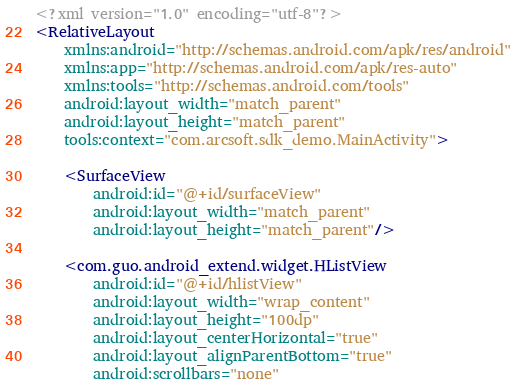<code> <loc_0><loc_0><loc_500><loc_500><_XML_><?xml version="1.0" encoding="utf-8"?>
<RelativeLayout
    xmlns:android="http://schemas.android.com/apk/res/android"
    xmlns:app="http://schemas.android.com/apk/res-auto"
    xmlns:tools="http://schemas.android.com/tools"
    android:layout_width="match_parent"
    android:layout_height="match_parent"
    tools:context="com.arcsoft.sdk_demo.MainActivity">

    <SurfaceView
        android:id="@+id/surfaceView"
        android:layout_width="match_parent"
        android:layout_height="match_parent"/>

    <com.guo.android_extend.widget.HListView
        android:id="@+id/hlistView"
        android:layout_width="wrap_content"
        android:layout_height="100dp"
        android:layout_centerHorizontal="true"
        android:layout_alignParentBottom="true"
        android:scrollbars="none"</code> 